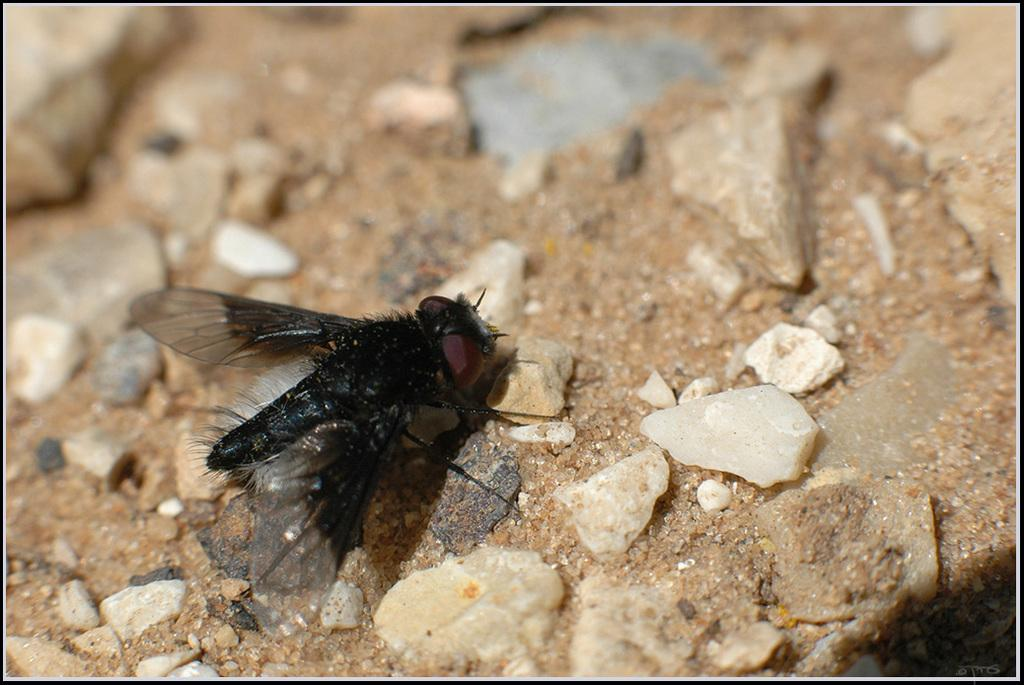What type of creature can be seen in the image? There is an insect in the image. What type of terrain is visible in the image? There is sand in the image. What other objects can be seen in the image? There are stones in the image. Where are the cherries that the baby and dad are picking in the image? There are no cherries, baby, or dad present in the image. What type of creature is shown interacting with the cherries in the image? There is no creature shown interacting with cherries in the image; it features an insect, sand, and stones. 